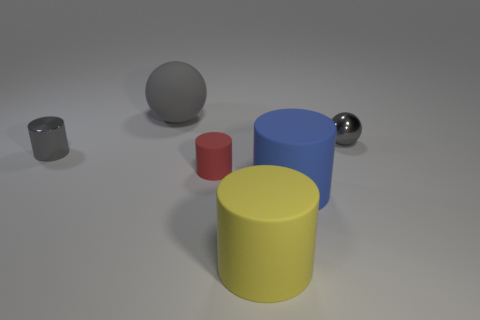Add 2 large blue matte objects. How many objects exist? 8 Subtract all spheres. How many objects are left? 4 Subtract 0 green blocks. How many objects are left? 6 Subtract all red matte things. Subtract all small blue objects. How many objects are left? 5 Add 1 tiny red objects. How many tiny red objects are left? 2 Add 1 big blue cylinders. How many big blue cylinders exist? 2 